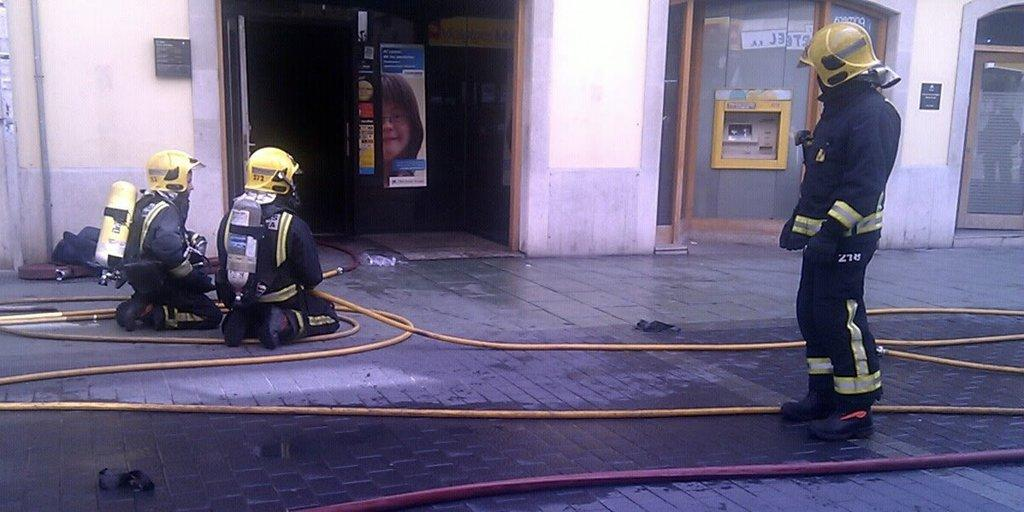Who or what can be seen in the image? There are people in the image. What objects are on the ground in the image? There are pipes on the ground in the image. What can be seen in the background of the image? There is a wall, posters, and some objects visible in the background of the image. What type of leather is being used to make the airplane visible in the image? There is no airplane visible in the image, and therefore no leather can be associated with it. 